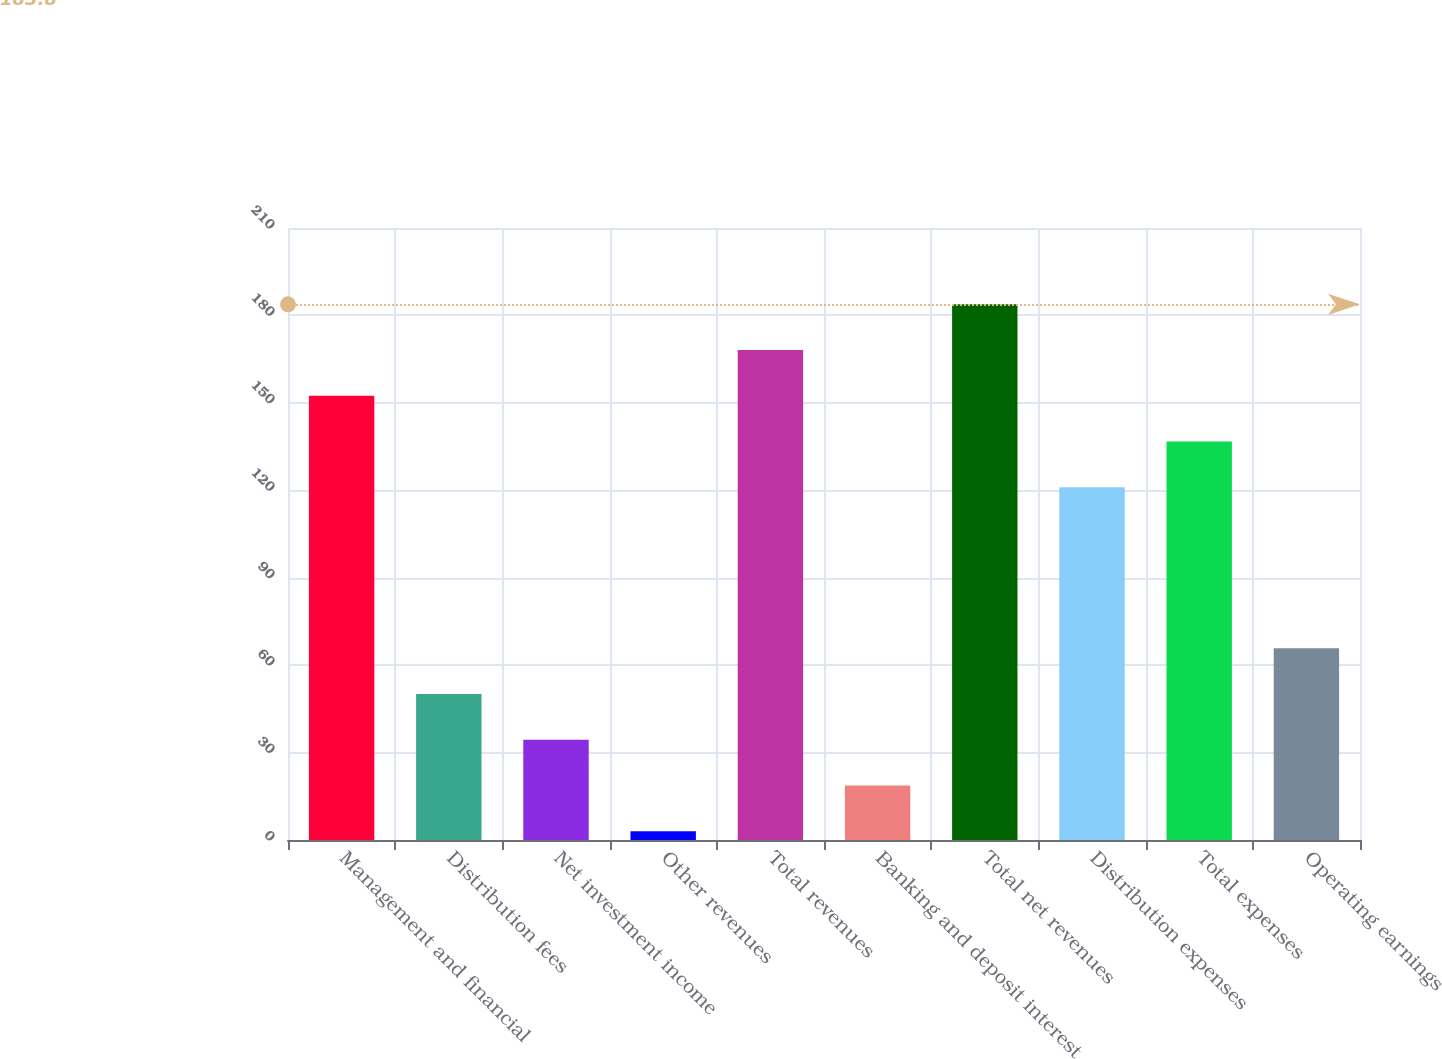Convert chart. <chart><loc_0><loc_0><loc_500><loc_500><bar_chart><fcel>Management and financial<fcel>Distribution fees<fcel>Net investment income<fcel>Other revenues<fcel>Total revenues<fcel>Banking and deposit interest<fcel>Total net revenues<fcel>Distribution expenses<fcel>Total expenses<fcel>Operating earnings<nl><fcel>152.4<fcel>50.1<fcel>34.4<fcel>3<fcel>168.1<fcel>18.7<fcel>183.8<fcel>121<fcel>136.7<fcel>65.8<nl></chart> 